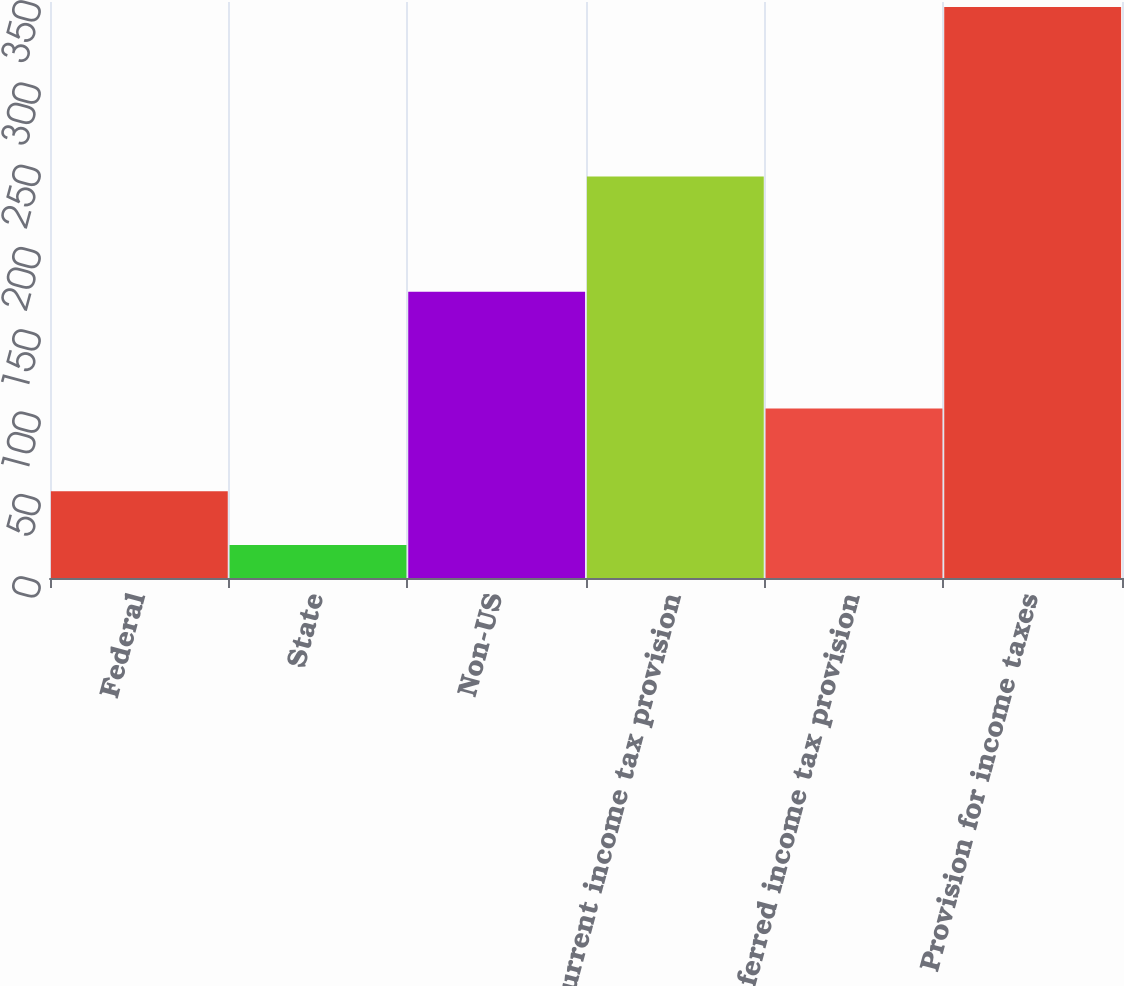Convert chart. <chart><loc_0><loc_0><loc_500><loc_500><bar_chart><fcel>Federal<fcel>State<fcel>Non-US<fcel>Current income tax provision<fcel>Deferred income tax provision<fcel>Provision for income taxes<nl><fcel>52.7<fcel>20<fcel>174<fcel>244<fcel>103<fcel>347<nl></chart> 